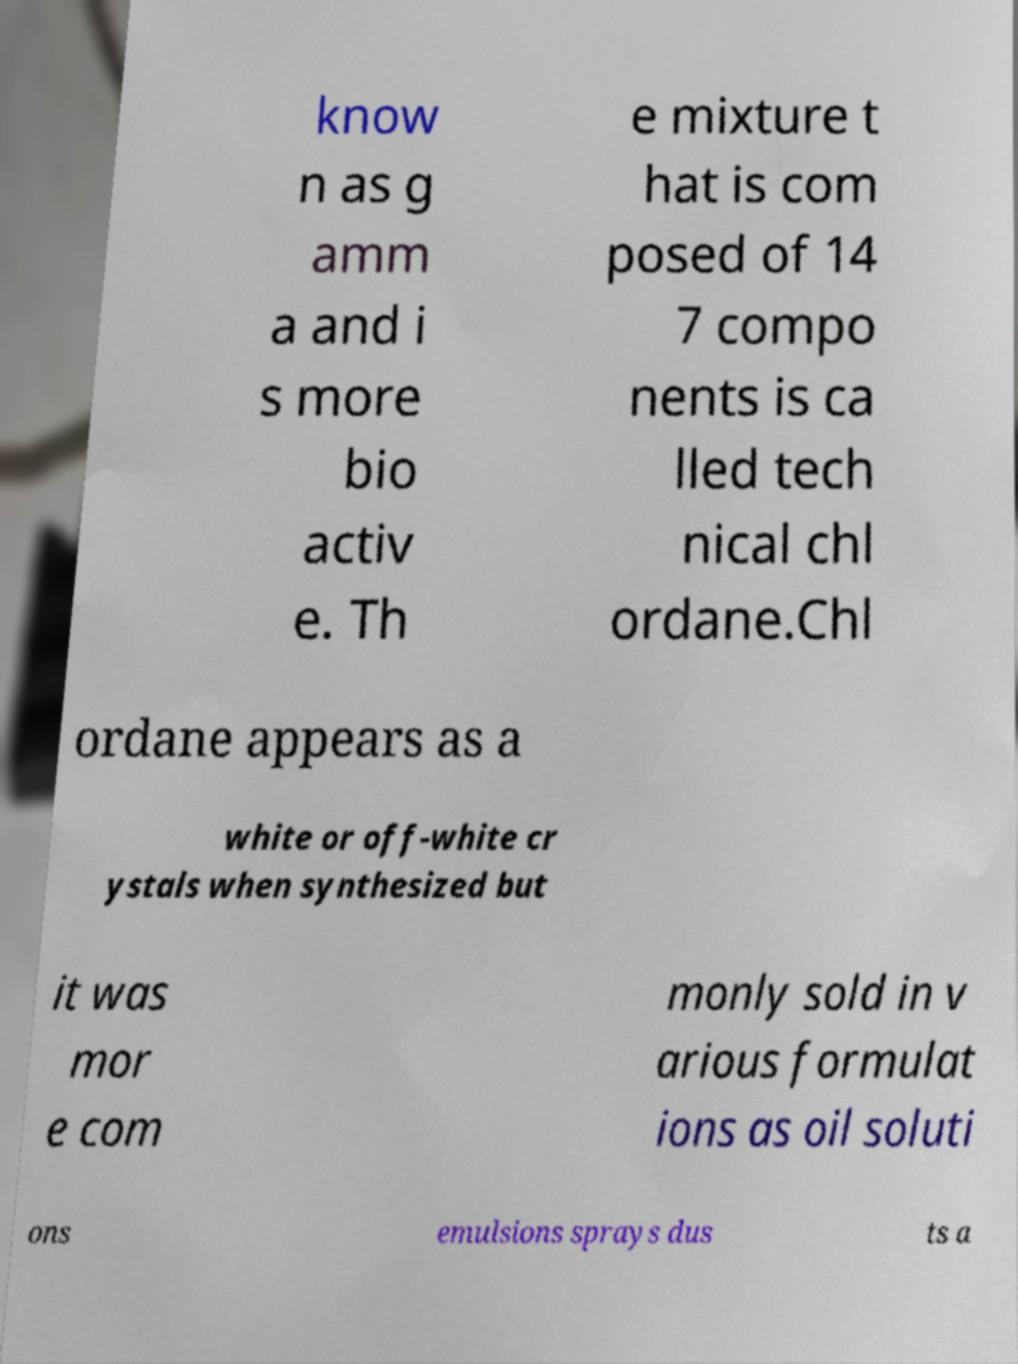Could you extract and type out the text from this image? know n as g amm a and i s more bio activ e. Th e mixture t hat is com posed of 14 7 compo nents is ca lled tech nical chl ordane.Chl ordane appears as a white or off-white cr ystals when synthesized but it was mor e com monly sold in v arious formulat ions as oil soluti ons emulsions sprays dus ts a 